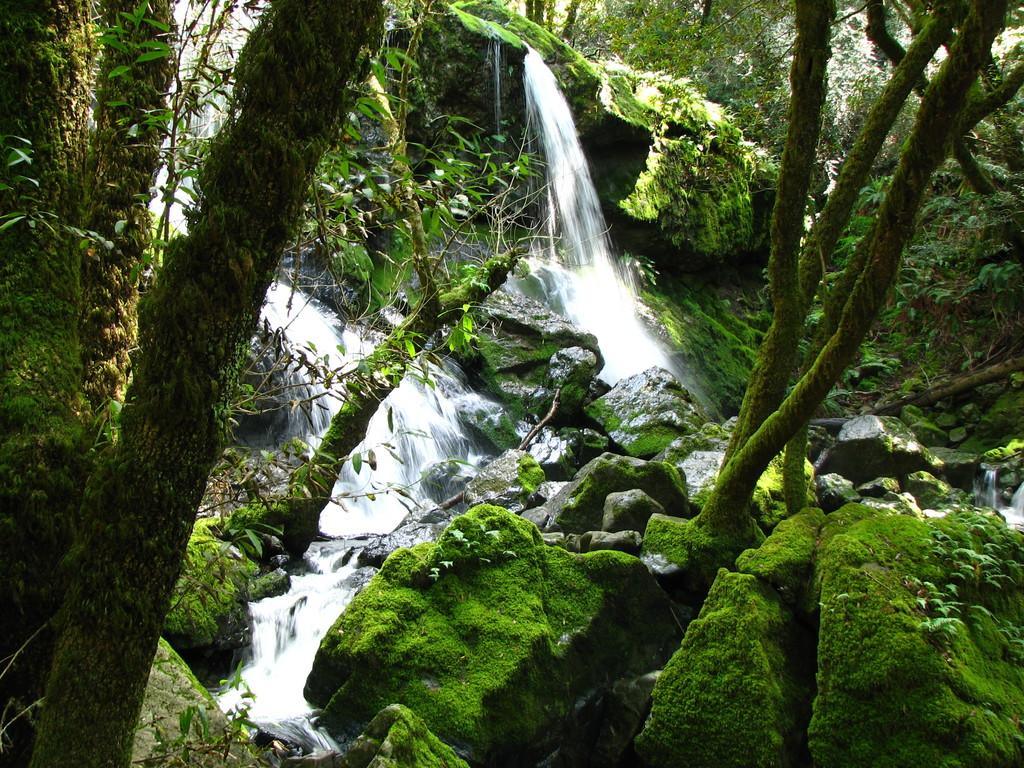What type of vegetation can be seen in the image? There are trees in the image. What is the color of the trees? The trees are green in color. What other elements can be seen in the background of the image? There are stones and a waterfall visible in the background of the image. How does the thrill of the flight affect the dust in the image? There is no flight or dust present in the image; it features trees, stones, and a waterfall. 